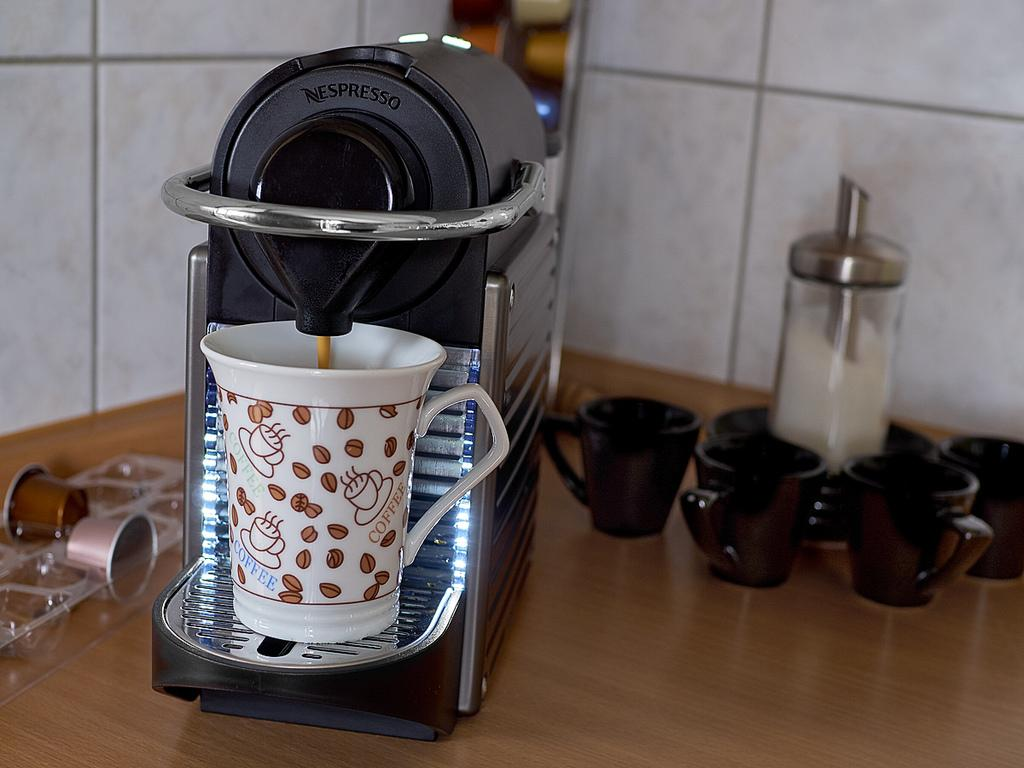What appliance is located on the left side of the image? There is a coffee machine on the left side of the image. What else can be seen in the image besides the coffee machine? There are cups and a jug of milk visible in the image. Where is the door to the fruit storage room in the image? There is no door or fruit storage room present in the image; it only features a coffee machine, cups, and a jug of milk. 